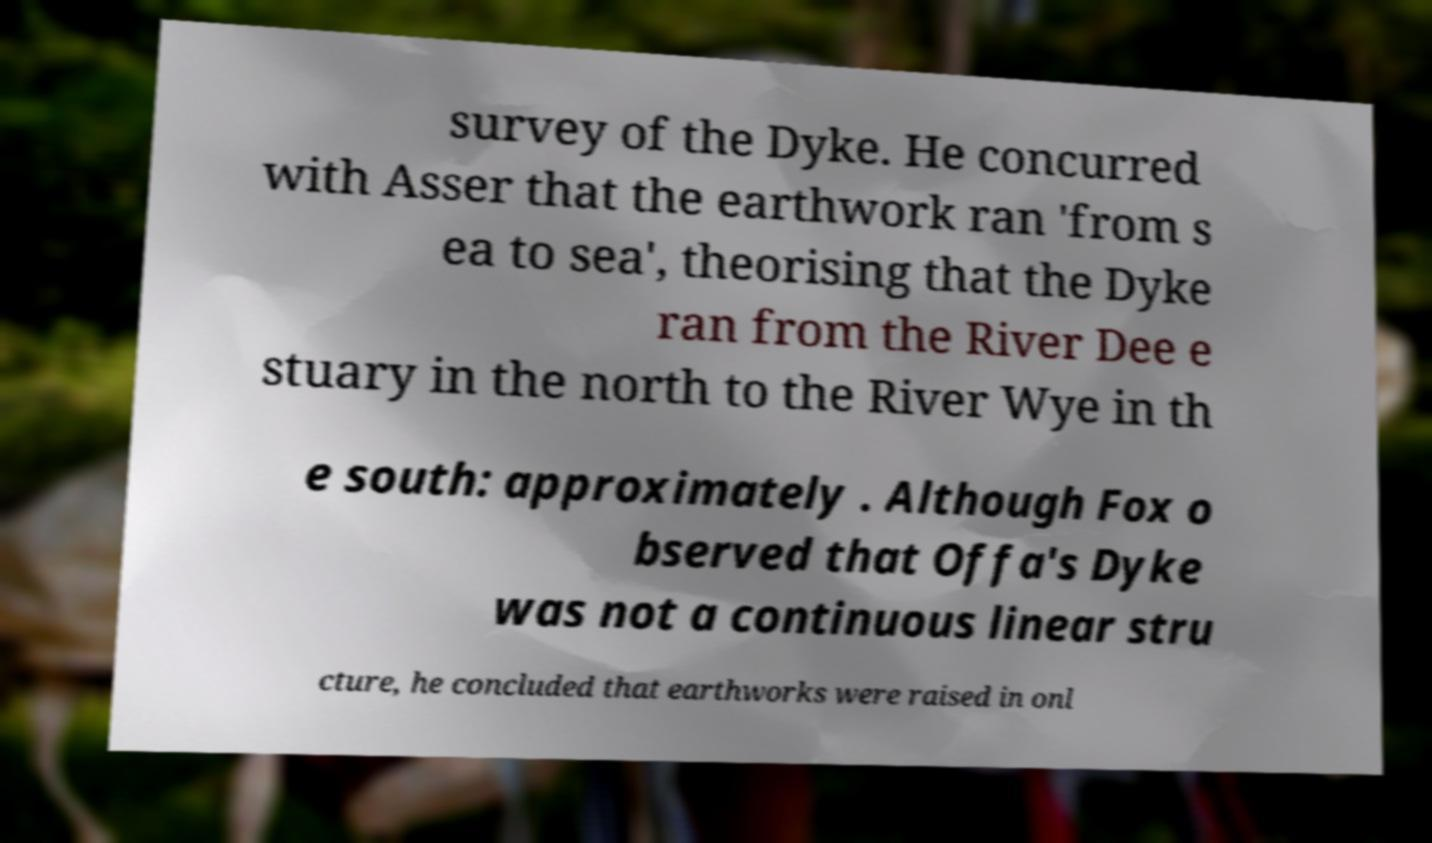Please identify and transcribe the text found in this image. survey of the Dyke. He concurred with Asser that the earthwork ran 'from s ea to sea', theorising that the Dyke ran from the River Dee e stuary in the north to the River Wye in th e south: approximately . Although Fox o bserved that Offa's Dyke was not a continuous linear stru cture, he concluded that earthworks were raised in onl 